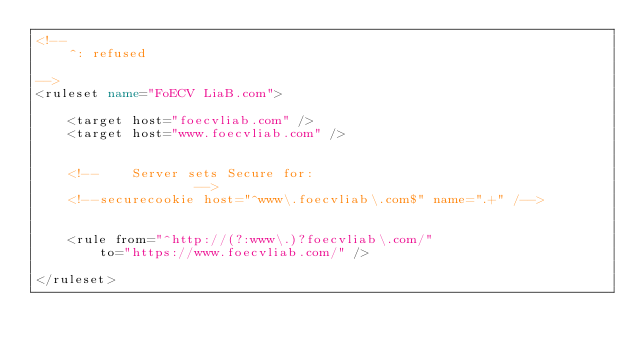<code> <loc_0><loc_0><loc_500><loc_500><_XML_><!--
	^: refused

-->
<ruleset name="FoECV LiaB.com">

	<target host="foecvliab.com" />
	<target host="www.foecvliab.com" />


	<!--	Server sets Secure for:
					-->
	<!--securecookie host="^www\.foecvliab\.com$" name=".+" /-->


	<rule from="^http://(?:www\.)?foecvliab\.com/"
		to="https://www.foecvliab.com/" />

</ruleset>
</code> 